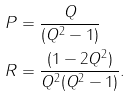Convert formula to latex. <formula><loc_0><loc_0><loc_500><loc_500>P & = \frac { Q } { ( Q ^ { 2 } - 1 ) } \\ R & = \frac { ( 1 - 2 Q ^ { 2 } ) } { Q ^ { 2 } ( Q ^ { 2 } - 1 ) } .</formula> 